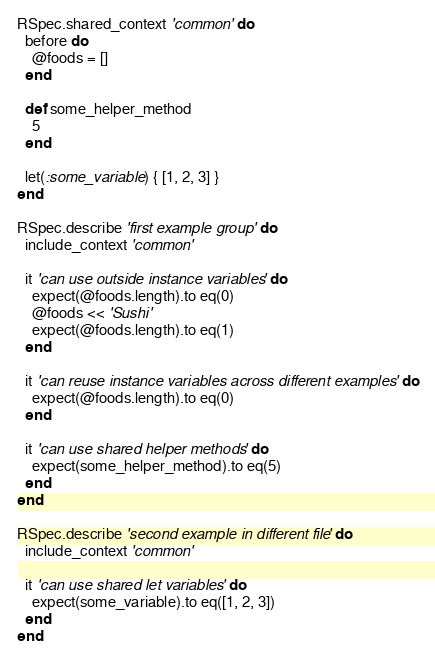<code> <loc_0><loc_0><loc_500><loc_500><_Ruby_>RSpec.shared_context 'common' do
  before do
    @foods = []
  end

  def some_helper_method
    5
  end

  let(:some_variable) { [1, 2, 3] }
end

RSpec.describe 'first example group' do
  include_context 'common'

  it 'can use outside instance variables' do
    expect(@foods.length).to eq(0)
    @foods << 'Sushi'
    expect(@foods.length).to eq(1)
  end

  it 'can reuse instance variables across different examples' do
    expect(@foods.length).to eq(0)
  end

  it 'can use shared helper methods' do
    expect(some_helper_method).to eq(5)
  end
end

RSpec.describe 'second example in different file' do
  include_context 'common'

  it 'can use shared let variables' do
    expect(some_variable).to eq([1, 2, 3])
  end
end</code> 